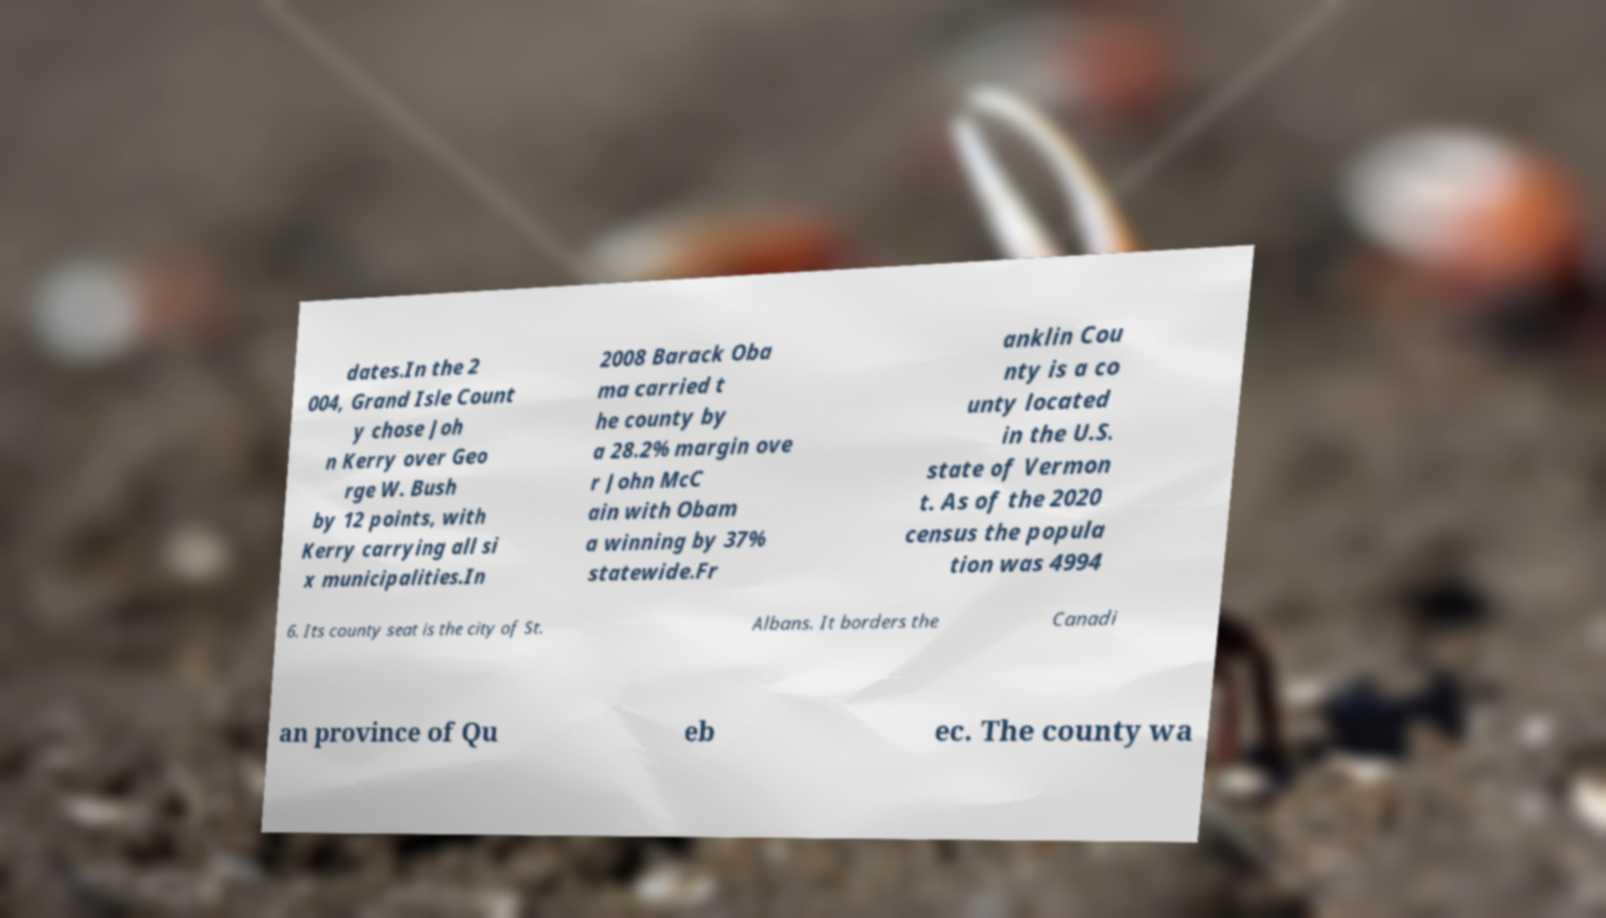Can you accurately transcribe the text from the provided image for me? dates.In the 2 004, Grand Isle Count y chose Joh n Kerry over Geo rge W. Bush by 12 points, with Kerry carrying all si x municipalities.In 2008 Barack Oba ma carried t he county by a 28.2% margin ove r John McC ain with Obam a winning by 37% statewide.Fr anklin Cou nty is a co unty located in the U.S. state of Vermon t. As of the 2020 census the popula tion was 4994 6. Its county seat is the city of St. Albans. It borders the Canadi an province of Qu eb ec. The county wa 